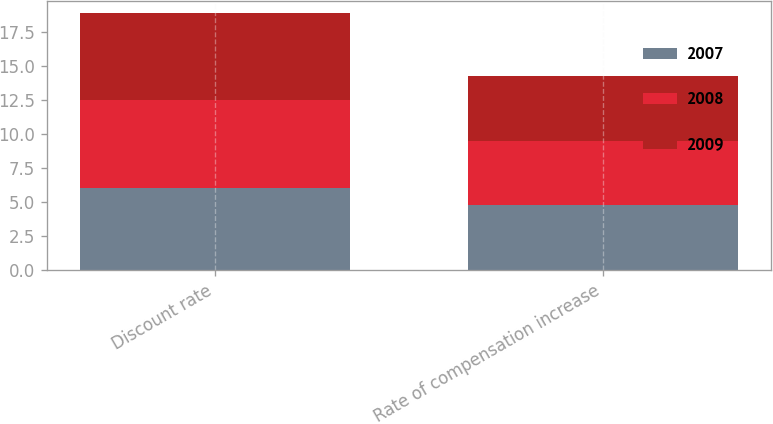<chart> <loc_0><loc_0><loc_500><loc_500><stacked_bar_chart><ecel><fcel>Discount rate<fcel>Rate of compensation increase<nl><fcel>2007<fcel>6<fcel>4.75<nl><fcel>2008<fcel>6.5<fcel>4.75<nl><fcel>2009<fcel>6.39<fcel>4.75<nl></chart> 